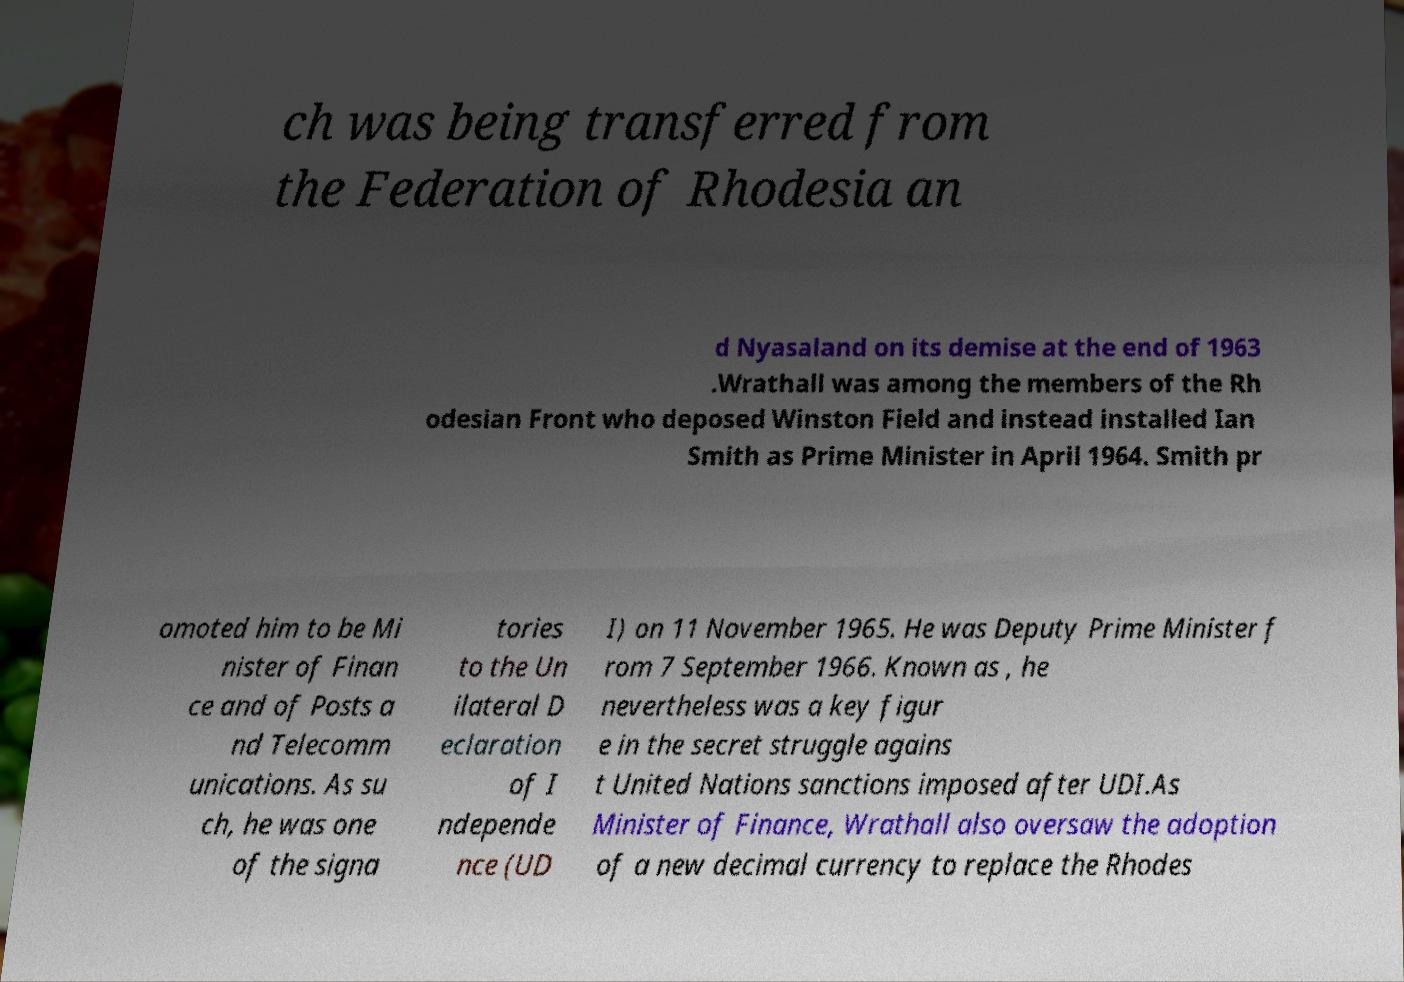I need the written content from this picture converted into text. Can you do that? ch was being transferred from the Federation of Rhodesia an d Nyasaland on its demise at the end of 1963 .Wrathall was among the members of the Rh odesian Front who deposed Winston Field and instead installed Ian Smith as Prime Minister in April 1964. Smith pr omoted him to be Mi nister of Finan ce and of Posts a nd Telecomm unications. As su ch, he was one of the signa tories to the Un ilateral D eclaration of I ndepende nce (UD I) on 11 November 1965. He was Deputy Prime Minister f rom 7 September 1966. Known as , he nevertheless was a key figur e in the secret struggle agains t United Nations sanctions imposed after UDI.As Minister of Finance, Wrathall also oversaw the adoption of a new decimal currency to replace the Rhodes 